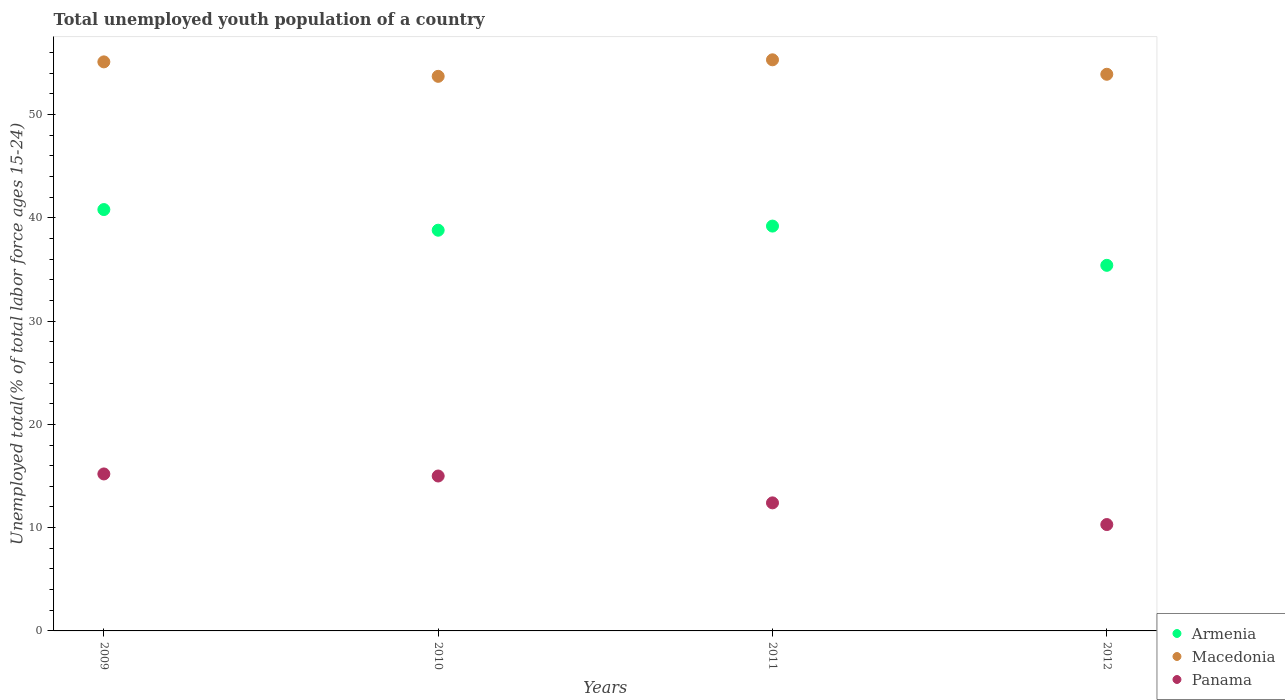How many different coloured dotlines are there?
Keep it short and to the point. 3. Is the number of dotlines equal to the number of legend labels?
Ensure brevity in your answer.  Yes. What is the percentage of total unemployed youth population of a country in Macedonia in 2009?
Ensure brevity in your answer.  55.1. Across all years, what is the maximum percentage of total unemployed youth population of a country in Armenia?
Your answer should be very brief. 40.8. Across all years, what is the minimum percentage of total unemployed youth population of a country in Macedonia?
Your response must be concise. 53.7. In which year was the percentage of total unemployed youth population of a country in Armenia minimum?
Your response must be concise. 2012. What is the total percentage of total unemployed youth population of a country in Macedonia in the graph?
Give a very brief answer. 218. What is the difference between the percentage of total unemployed youth population of a country in Armenia in 2009 and that in 2012?
Keep it short and to the point. 5.4. What is the difference between the percentage of total unemployed youth population of a country in Armenia in 2010 and the percentage of total unemployed youth population of a country in Panama in 2009?
Your answer should be compact. 23.6. What is the average percentage of total unemployed youth population of a country in Macedonia per year?
Provide a short and direct response. 54.5. In the year 2010, what is the difference between the percentage of total unemployed youth population of a country in Macedonia and percentage of total unemployed youth population of a country in Armenia?
Make the answer very short. 14.9. What is the ratio of the percentage of total unemployed youth population of a country in Panama in 2009 to that in 2012?
Provide a succinct answer. 1.48. Is the difference between the percentage of total unemployed youth population of a country in Macedonia in 2009 and 2010 greater than the difference between the percentage of total unemployed youth population of a country in Armenia in 2009 and 2010?
Keep it short and to the point. No. What is the difference between the highest and the second highest percentage of total unemployed youth population of a country in Armenia?
Offer a very short reply. 1.6. What is the difference between the highest and the lowest percentage of total unemployed youth population of a country in Panama?
Provide a short and direct response. 4.9. Is the sum of the percentage of total unemployed youth population of a country in Armenia in 2011 and 2012 greater than the maximum percentage of total unemployed youth population of a country in Macedonia across all years?
Keep it short and to the point. Yes. Is it the case that in every year, the sum of the percentage of total unemployed youth population of a country in Panama and percentage of total unemployed youth population of a country in Armenia  is greater than the percentage of total unemployed youth population of a country in Macedonia?
Ensure brevity in your answer.  No. Does the percentage of total unemployed youth population of a country in Panama monotonically increase over the years?
Provide a short and direct response. No. How many dotlines are there?
Your answer should be very brief. 3. Does the graph contain any zero values?
Provide a short and direct response. No. How many legend labels are there?
Your response must be concise. 3. What is the title of the graph?
Ensure brevity in your answer.  Total unemployed youth population of a country. Does "Vanuatu" appear as one of the legend labels in the graph?
Offer a very short reply. No. What is the label or title of the Y-axis?
Offer a very short reply. Unemployed total(% of total labor force ages 15-24). What is the Unemployed total(% of total labor force ages 15-24) of Armenia in 2009?
Provide a short and direct response. 40.8. What is the Unemployed total(% of total labor force ages 15-24) of Macedonia in 2009?
Provide a short and direct response. 55.1. What is the Unemployed total(% of total labor force ages 15-24) of Panama in 2009?
Provide a short and direct response. 15.2. What is the Unemployed total(% of total labor force ages 15-24) of Armenia in 2010?
Your response must be concise. 38.8. What is the Unemployed total(% of total labor force ages 15-24) of Macedonia in 2010?
Provide a succinct answer. 53.7. What is the Unemployed total(% of total labor force ages 15-24) of Panama in 2010?
Provide a short and direct response. 15. What is the Unemployed total(% of total labor force ages 15-24) of Armenia in 2011?
Provide a short and direct response. 39.2. What is the Unemployed total(% of total labor force ages 15-24) of Macedonia in 2011?
Your answer should be compact. 55.3. What is the Unemployed total(% of total labor force ages 15-24) of Panama in 2011?
Offer a very short reply. 12.4. What is the Unemployed total(% of total labor force ages 15-24) of Armenia in 2012?
Your response must be concise. 35.4. What is the Unemployed total(% of total labor force ages 15-24) of Macedonia in 2012?
Offer a terse response. 53.9. What is the Unemployed total(% of total labor force ages 15-24) in Panama in 2012?
Make the answer very short. 10.3. Across all years, what is the maximum Unemployed total(% of total labor force ages 15-24) of Armenia?
Your answer should be compact. 40.8. Across all years, what is the maximum Unemployed total(% of total labor force ages 15-24) of Macedonia?
Make the answer very short. 55.3. Across all years, what is the maximum Unemployed total(% of total labor force ages 15-24) of Panama?
Offer a terse response. 15.2. Across all years, what is the minimum Unemployed total(% of total labor force ages 15-24) in Armenia?
Provide a short and direct response. 35.4. Across all years, what is the minimum Unemployed total(% of total labor force ages 15-24) of Macedonia?
Give a very brief answer. 53.7. Across all years, what is the minimum Unemployed total(% of total labor force ages 15-24) of Panama?
Your answer should be very brief. 10.3. What is the total Unemployed total(% of total labor force ages 15-24) in Armenia in the graph?
Make the answer very short. 154.2. What is the total Unemployed total(% of total labor force ages 15-24) in Macedonia in the graph?
Your answer should be very brief. 218. What is the total Unemployed total(% of total labor force ages 15-24) of Panama in the graph?
Provide a succinct answer. 52.9. What is the difference between the Unemployed total(% of total labor force ages 15-24) of Armenia in 2009 and that in 2010?
Offer a terse response. 2. What is the difference between the Unemployed total(% of total labor force ages 15-24) of Panama in 2009 and that in 2010?
Offer a very short reply. 0.2. What is the difference between the Unemployed total(% of total labor force ages 15-24) in Macedonia in 2009 and that in 2011?
Keep it short and to the point. -0.2. What is the difference between the Unemployed total(% of total labor force ages 15-24) in Macedonia in 2009 and that in 2012?
Your answer should be compact. 1.2. What is the difference between the Unemployed total(% of total labor force ages 15-24) in Panama in 2009 and that in 2012?
Make the answer very short. 4.9. What is the difference between the Unemployed total(% of total labor force ages 15-24) of Armenia in 2009 and the Unemployed total(% of total labor force ages 15-24) of Panama in 2010?
Offer a terse response. 25.8. What is the difference between the Unemployed total(% of total labor force ages 15-24) in Macedonia in 2009 and the Unemployed total(% of total labor force ages 15-24) in Panama in 2010?
Your response must be concise. 40.1. What is the difference between the Unemployed total(% of total labor force ages 15-24) in Armenia in 2009 and the Unemployed total(% of total labor force ages 15-24) in Macedonia in 2011?
Ensure brevity in your answer.  -14.5. What is the difference between the Unemployed total(% of total labor force ages 15-24) in Armenia in 2009 and the Unemployed total(% of total labor force ages 15-24) in Panama in 2011?
Your response must be concise. 28.4. What is the difference between the Unemployed total(% of total labor force ages 15-24) in Macedonia in 2009 and the Unemployed total(% of total labor force ages 15-24) in Panama in 2011?
Your answer should be compact. 42.7. What is the difference between the Unemployed total(% of total labor force ages 15-24) in Armenia in 2009 and the Unemployed total(% of total labor force ages 15-24) in Macedonia in 2012?
Provide a short and direct response. -13.1. What is the difference between the Unemployed total(% of total labor force ages 15-24) in Armenia in 2009 and the Unemployed total(% of total labor force ages 15-24) in Panama in 2012?
Give a very brief answer. 30.5. What is the difference between the Unemployed total(% of total labor force ages 15-24) of Macedonia in 2009 and the Unemployed total(% of total labor force ages 15-24) of Panama in 2012?
Keep it short and to the point. 44.8. What is the difference between the Unemployed total(% of total labor force ages 15-24) in Armenia in 2010 and the Unemployed total(% of total labor force ages 15-24) in Macedonia in 2011?
Ensure brevity in your answer.  -16.5. What is the difference between the Unemployed total(% of total labor force ages 15-24) in Armenia in 2010 and the Unemployed total(% of total labor force ages 15-24) in Panama in 2011?
Your answer should be very brief. 26.4. What is the difference between the Unemployed total(% of total labor force ages 15-24) in Macedonia in 2010 and the Unemployed total(% of total labor force ages 15-24) in Panama in 2011?
Make the answer very short. 41.3. What is the difference between the Unemployed total(% of total labor force ages 15-24) of Armenia in 2010 and the Unemployed total(% of total labor force ages 15-24) of Macedonia in 2012?
Keep it short and to the point. -15.1. What is the difference between the Unemployed total(% of total labor force ages 15-24) of Macedonia in 2010 and the Unemployed total(% of total labor force ages 15-24) of Panama in 2012?
Your response must be concise. 43.4. What is the difference between the Unemployed total(% of total labor force ages 15-24) in Armenia in 2011 and the Unemployed total(% of total labor force ages 15-24) in Macedonia in 2012?
Your answer should be very brief. -14.7. What is the difference between the Unemployed total(% of total labor force ages 15-24) of Armenia in 2011 and the Unemployed total(% of total labor force ages 15-24) of Panama in 2012?
Keep it short and to the point. 28.9. What is the average Unemployed total(% of total labor force ages 15-24) in Armenia per year?
Ensure brevity in your answer.  38.55. What is the average Unemployed total(% of total labor force ages 15-24) of Macedonia per year?
Make the answer very short. 54.5. What is the average Unemployed total(% of total labor force ages 15-24) of Panama per year?
Your answer should be very brief. 13.22. In the year 2009, what is the difference between the Unemployed total(% of total labor force ages 15-24) in Armenia and Unemployed total(% of total labor force ages 15-24) in Macedonia?
Ensure brevity in your answer.  -14.3. In the year 2009, what is the difference between the Unemployed total(% of total labor force ages 15-24) of Armenia and Unemployed total(% of total labor force ages 15-24) of Panama?
Your response must be concise. 25.6. In the year 2009, what is the difference between the Unemployed total(% of total labor force ages 15-24) in Macedonia and Unemployed total(% of total labor force ages 15-24) in Panama?
Your answer should be compact. 39.9. In the year 2010, what is the difference between the Unemployed total(% of total labor force ages 15-24) in Armenia and Unemployed total(% of total labor force ages 15-24) in Macedonia?
Offer a terse response. -14.9. In the year 2010, what is the difference between the Unemployed total(% of total labor force ages 15-24) of Armenia and Unemployed total(% of total labor force ages 15-24) of Panama?
Provide a short and direct response. 23.8. In the year 2010, what is the difference between the Unemployed total(% of total labor force ages 15-24) of Macedonia and Unemployed total(% of total labor force ages 15-24) of Panama?
Ensure brevity in your answer.  38.7. In the year 2011, what is the difference between the Unemployed total(% of total labor force ages 15-24) in Armenia and Unemployed total(% of total labor force ages 15-24) in Macedonia?
Your answer should be very brief. -16.1. In the year 2011, what is the difference between the Unemployed total(% of total labor force ages 15-24) in Armenia and Unemployed total(% of total labor force ages 15-24) in Panama?
Ensure brevity in your answer.  26.8. In the year 2011, what is the difference between the Unemployed total(% of total labor force ages 15-24) of Macedonia and Unemployed total(% of total labor force ages 15-24) of Panama?
Provide a succinct answer. 42.9. In the year 2012, what is the difference between the Unemployed total(% of total labor force ages 15-24) of Armenia and Unemployed total(% of total labor force ages 15-24) of Macedonia?
Your response must be concise. -18.5. In the year 2012, what is the difference between the Unemployed total(% of total labor force ages 15-24) of Armenia and Unemployed total(% of total labor force ages 15-24) of Panama?
Offer a terse response. 25.1. In the year 2012, what is the difference between the Unemployed total(% of total labor force ages 15-24) of Macedonia and Unemployed total(% of total labor force ages 15-24) of Panama?
Keep it short and to the point. 43.6. What is the ratio of the Unemployed total(% of total labor force ages 15-24) in Armenia in 2009 to that in 2010?
Provide a succinct answer. 1.05. What is the ratio of the Unemployed total(% of total labor force ages 15-24) of Macedonia in 2009 to that in 2010?
Ensure brevity in your answer.  1.03. What is the ratio of the Unemployed total(% of total labor force ages 15-24) of Panama in 2009 to that in 2010?
Ensure brevity in your answer.  1.01. What is the ratio of the Unemployed total(% of total labor force ages 15-24) in Armenia in 2009 to that in 2011?
Ensure brevity in your answer.  1.04. What is the ratio of the Unemployed total(% of total labor force ages 15-24) in Macedonia in 2009 to that in 2011?
Offer a very short reply. 1. What is the ratio of the Unemployed total(% of total labor force ages 15-24) of Panama in 2009 to that in 2011?
Keep it short and to the point. 1.23. What is the ratio of the Unemployed total(% of total labor force ages 15-24) of Armenia in 2009 to that in 2012?
Ensure brevity in your answer.  1.15. What is the ratio of the Unemployed total(% of total labor force ages 15-24) of Macedonia in 2009 to that in 2012?
Your response must be concise. 1.02. What is the ratio of the Unemployed total(% of total labor force ages 15-24) of Panama in 2009 to that in 2012?
Provide a short and direct response. 1.48. What is the ratio of the Unemployed total(% of total labor force ages 15-24) in Macedonia in 2010 to that in 2011?
Give a very brief answer. 0.97. What is the ratio of the Unemployed total(% of total labor force ages 15-24) in Panama in 2010 to that in 2011?
Give a very brief answer. 1.21. What is the ratio of the Unemployed total(% of total labor force ages 15-24) of Armenia in 2010 to that in 2012?
Offer a very short reply. 1.1. What is the ratio of the Unemployed total(% of total labor force ages 15-24) in Macedonia in 2010 to that in 2012?
Ensure brevity in your answer.  1. What is the ratio of the Unemployed total(% of total labor force ages 15-24) in Panama in 2010 to that in 2012?
Your answer should be very brief. 1.46. What is the ratio of the Unemployed total(% of total labor force ages 15-24) in Armenia in 2011 to that in 2012?
Give a very brief answer. 1.11. What is the ratio of the Unemployed total(% of total labor force ages 15-24) of Macedonia in 2011 to that in 2012?
Provide a short and direct response. 1.03. What is the ratio of the Unemployed total(% of total labor force ages 15-24) in Panama in 2011 to that in 2012?
Give a very brief answer. 1.2. 